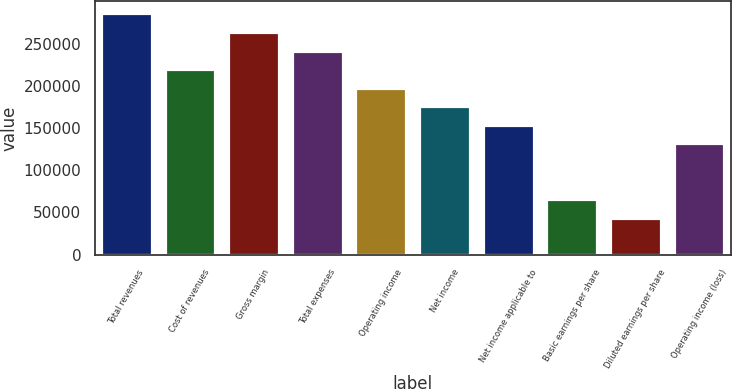Convert chart. <chart><loc_0><loc_0><loc_500><loc_500><bar_chart><fcel>Total revenues<fcel>Cost of revenues<fcel>Gross margin<fcel>Total expenses<fcel>Operating income<fcel>Net income<fcel>Net income applicable to<fcel>Basic earnings per share<fcel>Diluted earnings per share<fcel>Operating income (loss)<nl><fcel>285592<fcel>219686<fcel>263623<fcel>241655<fcel>197717<fcel>175749<fcel>153780<fcel>65905.8<fcel>43937.2<fcel>131812<nl></chart> 